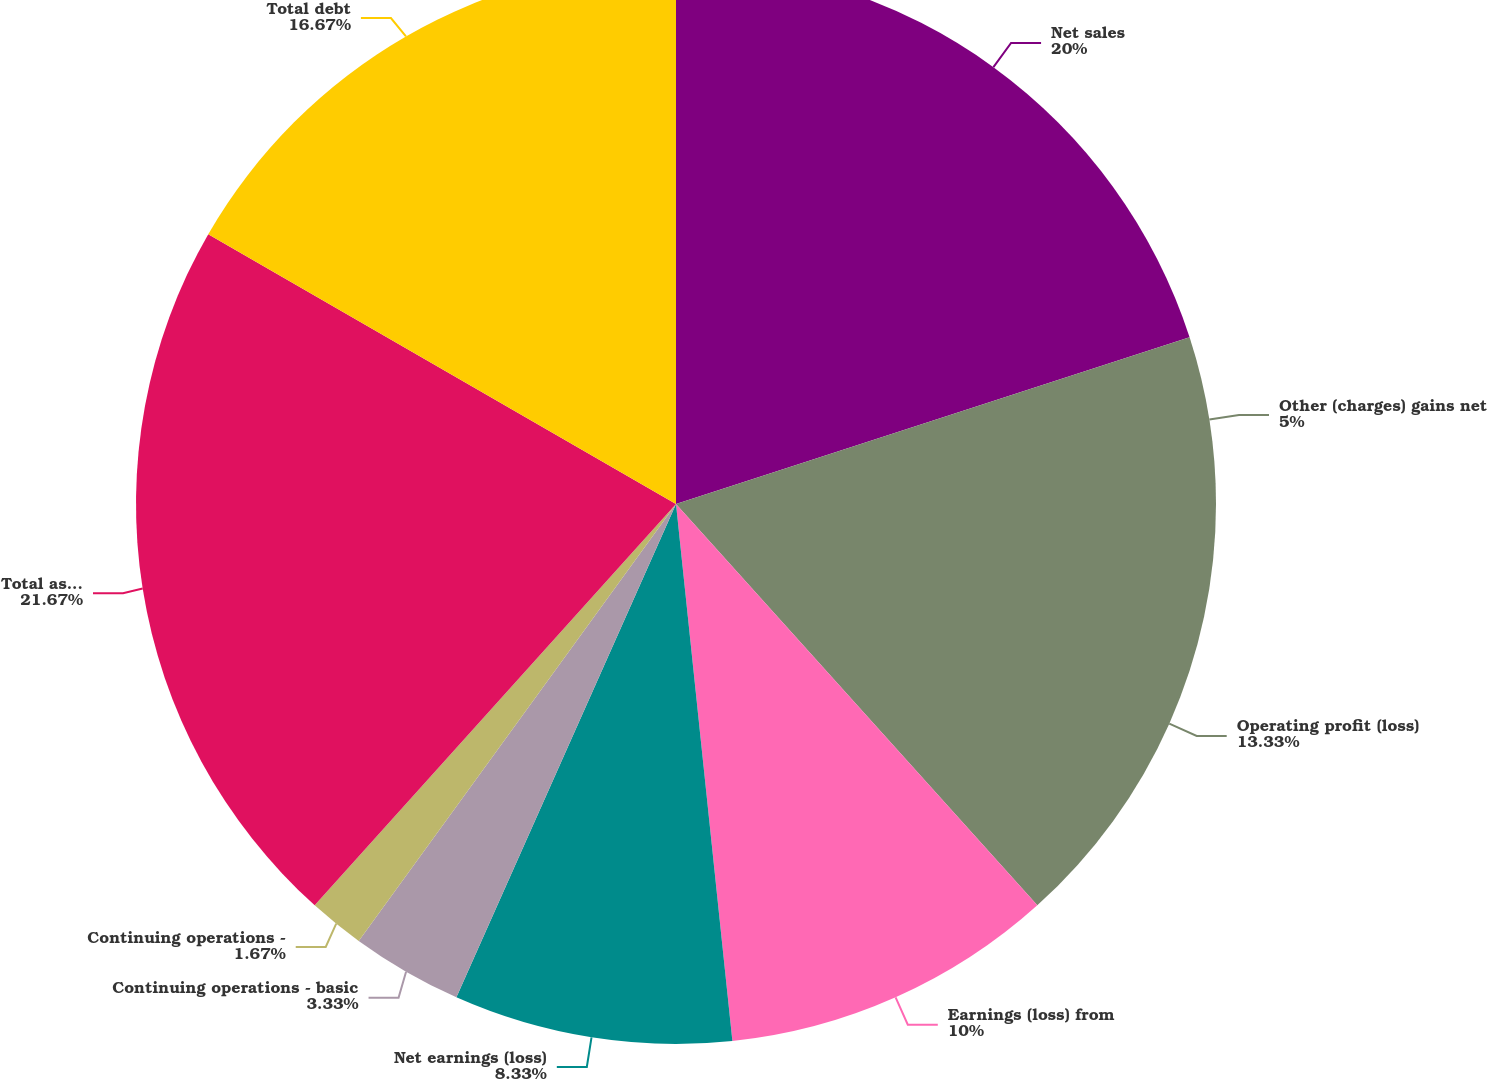Convert chart. <chart><loc_0><loc_0><loc_500><loc_500><pie_chart><fcel>Net sales<fcel>Other (charges) gains net<fcel>Operating profit (loss)<fcel>Earnings (loss) from<fcel>Net earnings (loss)<fcel>Continuing operations - basic<fcel>Continuing operations -<fcel>Total assets<fcel>Total debt<nl><fcel>20.0%<fcel>5.0%<fcel>13.33%<fcel>10.0%<fcel>8.33%<fcel>3.33%<fcel>1.67%<fcel>21.66%<fcel>16.67%<nl></chart> 